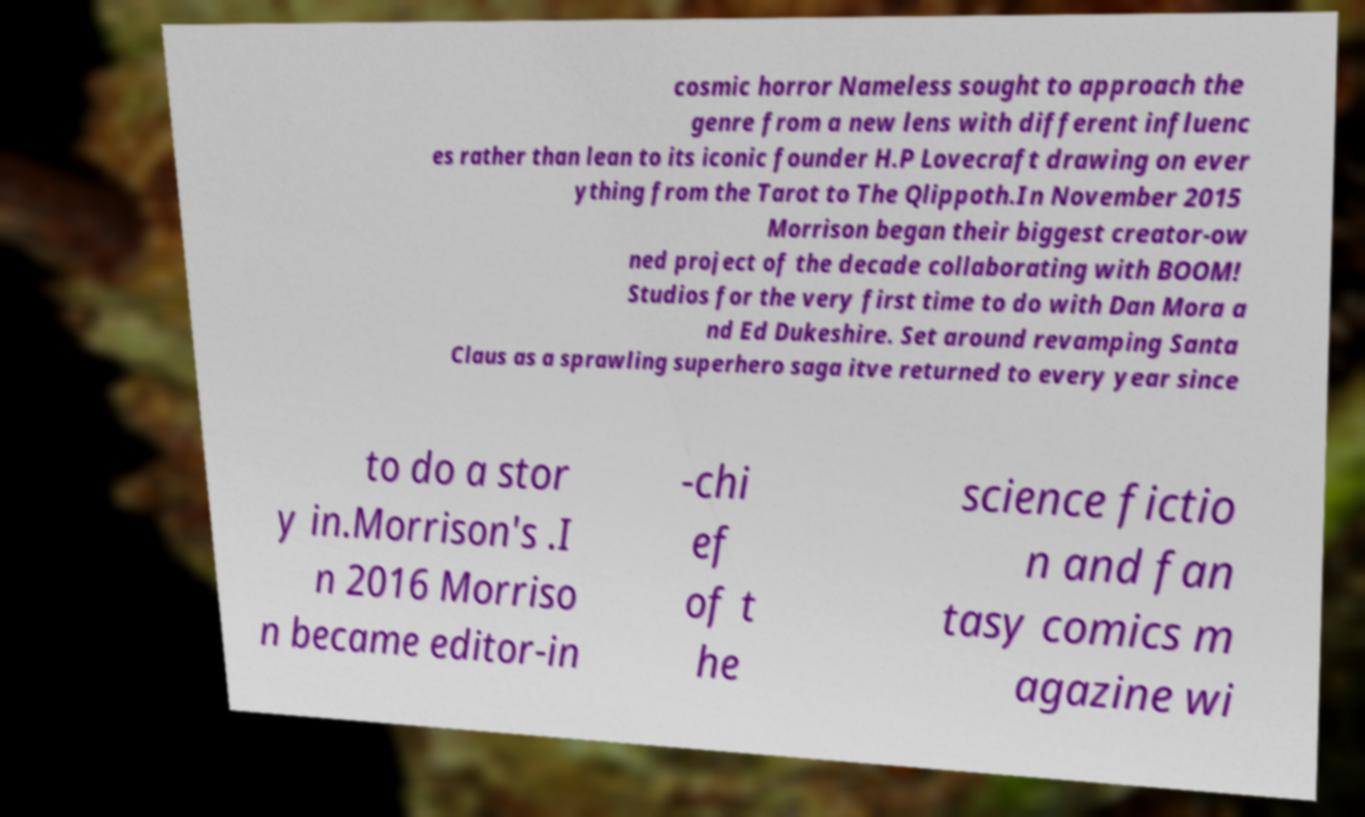Please read and relay the text visible in this image. What does it say? cosmic horror Nameless sought to approach the genre from a new lens with different influenc es rather than lean to its iconic founder H.P Lovecraft drawing on ever ything from the Tarot to The Qlippoth.In November 2015 Morrison began their biggest creator-ow ned project of the decade collaborating with BOOM! Studios for the very first time to do with Dan Mora a nd Ed Dukeshire. Set around revamping Santa Claus as a sprawling superhero saga itve returned to every year since to do a stor y in.Morrison's .I n 2016 Morriso n became editor-in -chi ef of t he science fictio n and fan tasy comics m agazine wi 